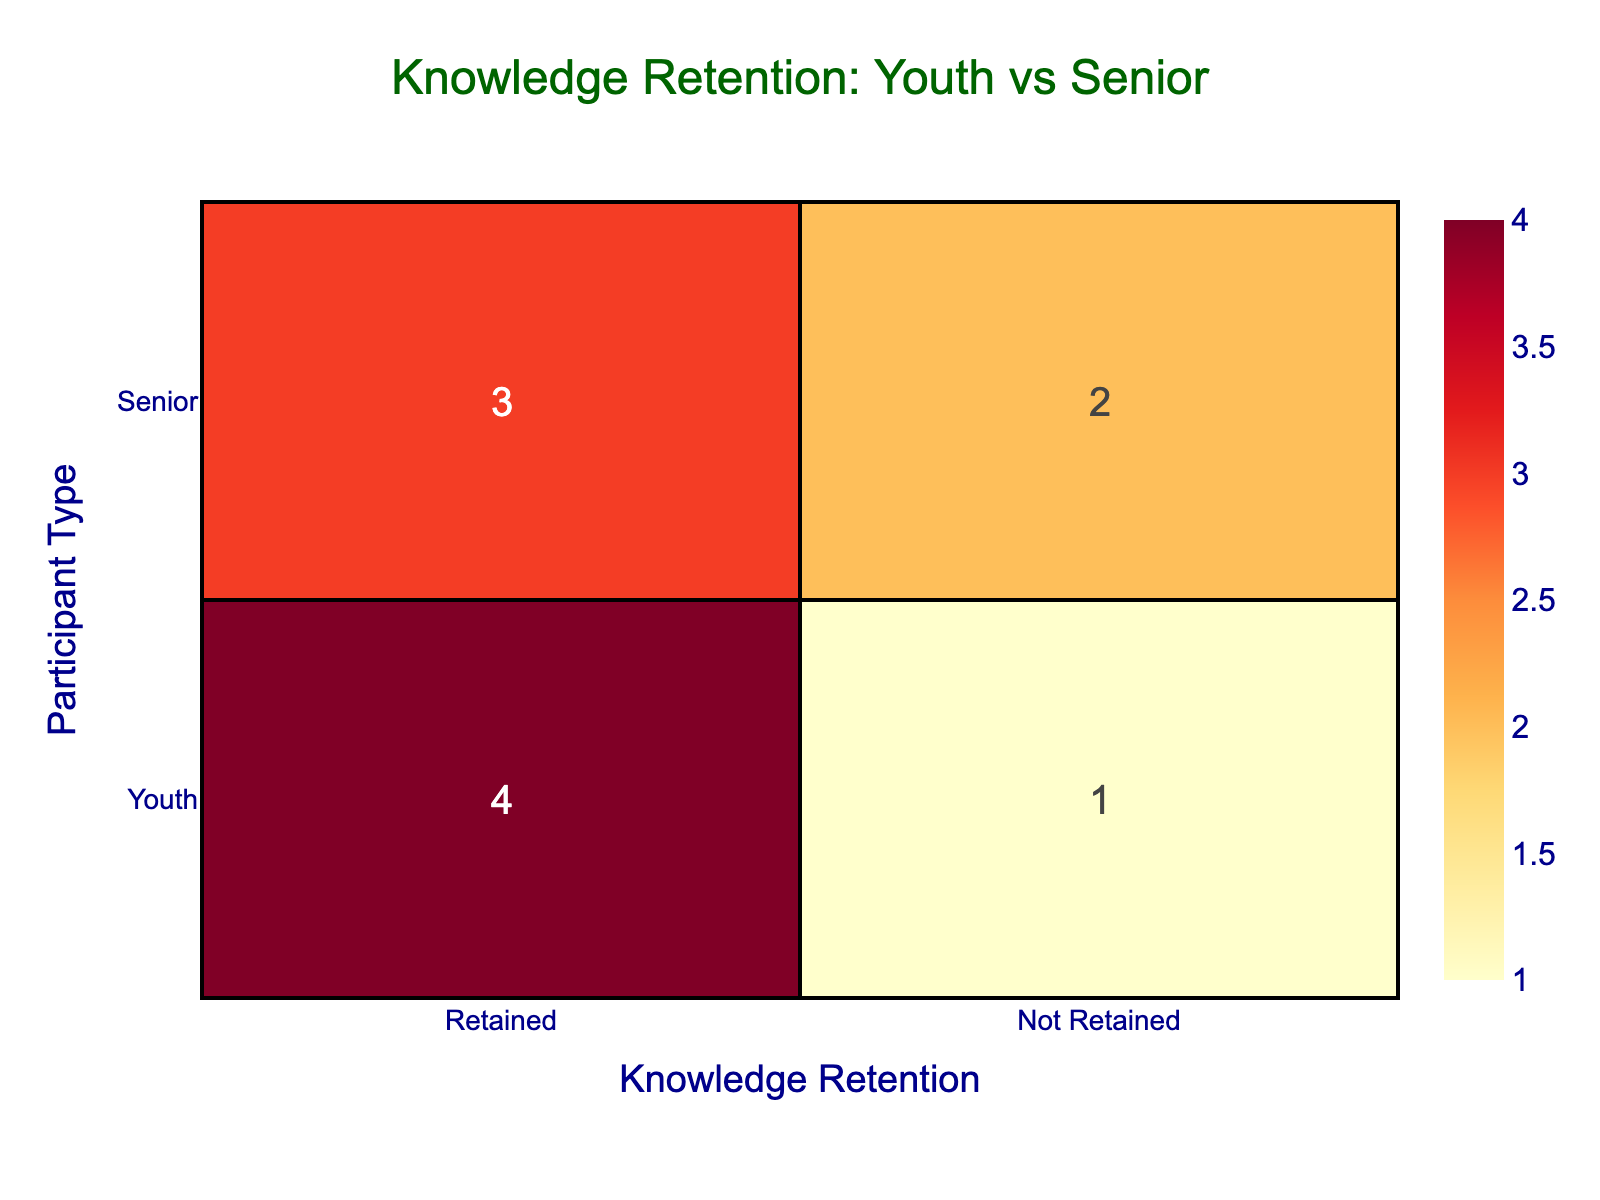What is the number of Youth participants who retained knowledge? The table shows that there are 3 Youth participants who retained knowledge. This can be seen in the cells under the 'Retained' category for 'Youth'.
Answer: 3 How many Senior participants did not retain their knowledge? According to the table, there are 2 Senior participants who did not retain their knowledge. This is found in the 'Not Retained' category for 'Senior'.
Answer: 2 What is the total number of Youth participants in the study? There are 5 Youth participants in total, which is determined by counting the rows labeled as 'Youth' in the table.
Answer: 5 Did any Senior participants retain Knowledge while having a low pre-workshop score? Yes, there were 2 Senior participants who retained knowledge despite having a low pre-workshop score. They are reflected in the 'Retained' row for 'Senior' with specific past scores listed in the data.
Answer: Yes How many more Youth participants retained knowledge compared to Senior participants? Youth participants who retained knowledge number 3, while Senior participants who retained knowledge also number 3. Thus, the difference is 3 - 3 = 0, meaning there is no difference in retention between the two groups.
Answer: 0 What percentage of Youth participants did not retain knowledge? Out of 5 Youths, 2 did not retain knowledge; thus, the percentage of Youth participants who did not retain knowledge is (2/5)*100 = 40%.
Answer: 40% Is it true that all Senior participants with a high pre-workshop score retained their knowledge? Yes, it is true, as indicated by the table showing that among Senior participants, both who began with a high score retained their knowledge.
Answer: Yes What is the total number of participants who retained knowledge? Summing the retained participants, 3 Youths and 3 Seniors equals 6 participants who retained knowledge in total.
Answer: 6 What was the Knowledge Retention status for participants with a Medium pre-workshop score? For the Medium pre-workshop score, 3 Youths retained knowledge while 1 Senior did not retain knowledge. This means among the Medium pre-scores, there is a mix of retention statuses shown in the table.
Answer: Mixed 